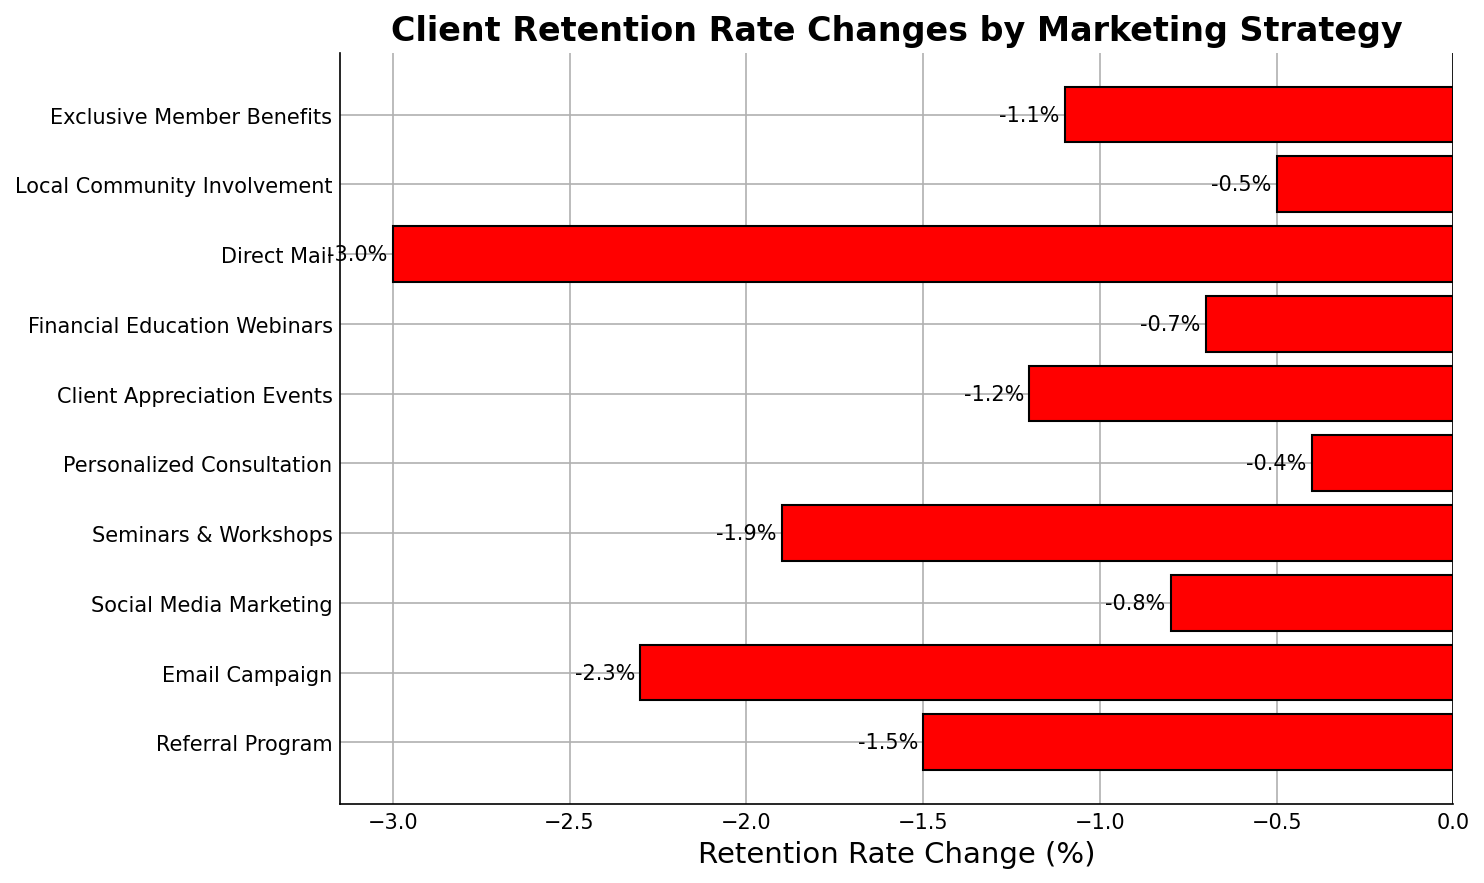Which marketing strategy had the smallest decrease in client retention rate? The smallest decrease can be identified by looking at the bar with the least negative value. The Personalized Consultation strategy shows a decrease of -0.4%, which is the smallest drop among all the strategies.
Answer: Personalized Consultation Which marketing strategy had the largest decrease in client retention rate? The largest decrease can be identified by finding the bar with the most negative value. The Direct Mail strategy shows a decrease of -3.0%, which is the largest drop among all the strategies.
Answer: Direct Mail What is the difference in retention rate change between the Referral Program and Email Campaign? The Referral Program's retention rate change is -1.5% and the Email Campaign's is -2.3%. The difference is calculated as -1.5% - (-2.3%) = -1.5% + 2.3% = 0.8%.
Answer: 0.8% How many strategies had a retention rate decrease of more than -1.0% but less than -2.0%? The strategies that fall within this range are Referral Program (-1.5%), Seminars & Workshops (-1.9%), and Client Appreciation Events (-1.2%). This gives a total of 3 strategies.
Answer: 3 Which decreases more: Seminars & Workshops or Client Appreciation Events? The Seminars & Workshops strategy had a decrease of -1.9% while the Client Appreciation Events had a decrease of -1.2%. Comparing these, -1.9% is more negative than -1.2%.
Answer: Seminars & Workshops What is the combined retention rate change for strategies with less than -1.0% decrease? The strategies with less than -1.0% decrease are Referral Program (-1.5%), Email Campaign (-2.3%), Seminars & Workshops (-1.9%), Client Appreciation Events (-1.2%), and Direct Mail (-3.0%). Combined, this is -1.5% + -2.3% + -1.9% + -1.2% + -3.0% = -9.9%.
Answer: -9.9% What's the average retention rate decrease for all strategies? Sum up all the retention rate changes and divide by the number of strategies: (-1.5 - 2.3 - 0.8 - 1.9 - 0.4 - 1.2 - 0.7 - 3.0 - 0.5 - 1.1) / 10 = -13.4 / 10 = -1.34%.
Answer: -1.34% Which marketing strategy's retention rate change is closest to the average rate change? First calculate the average retention rate change: -1.34%. The strategy closest to this average is Exclusive Member Benefits with a change of -1.1%, which is the nearest to -1.34%.
Answer: Exclusive Member Benefits 